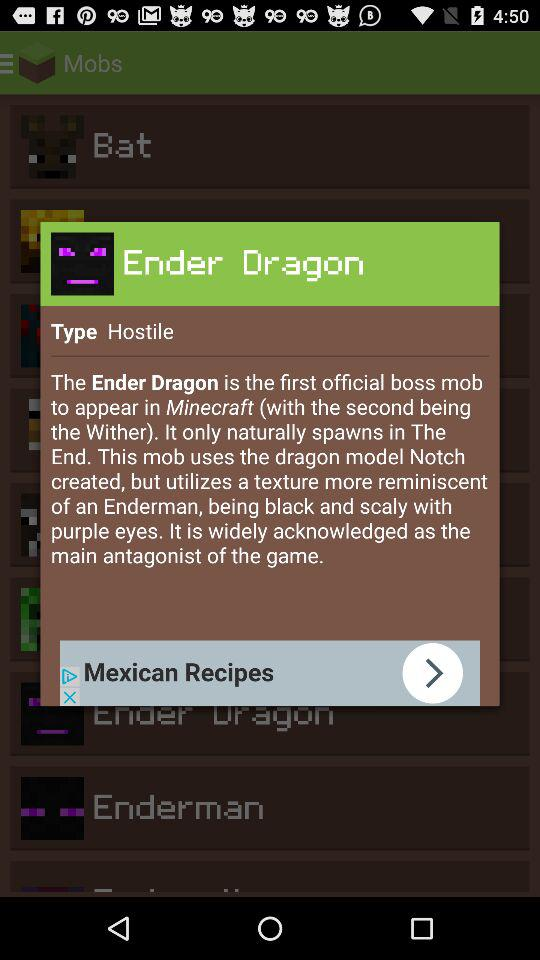What is the game ID? The game ID is 57. 